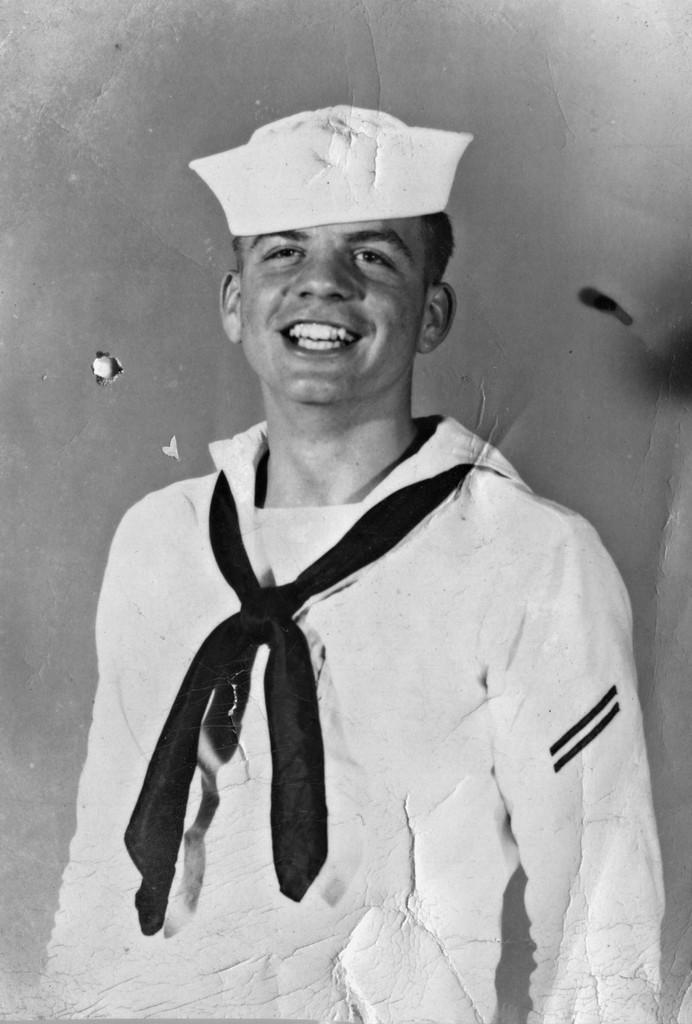Who is the main subject in the foreground of the image? There is a man in the foreground of the image. What is the man wearing on his upper body? The man is wearing a white dress. What is the man wearing around his neck? The man is wearing a black tie. What is the man wearing on his head? The man is wearing a white cap. Can you describe the background of the image? The background of the image is not clear. How many ants can be seen crawling on the man's white dress in the image? There are no ants visible in the image. What type of island is shown in the background of the image? There is no island present in the image; the background is not clear. 